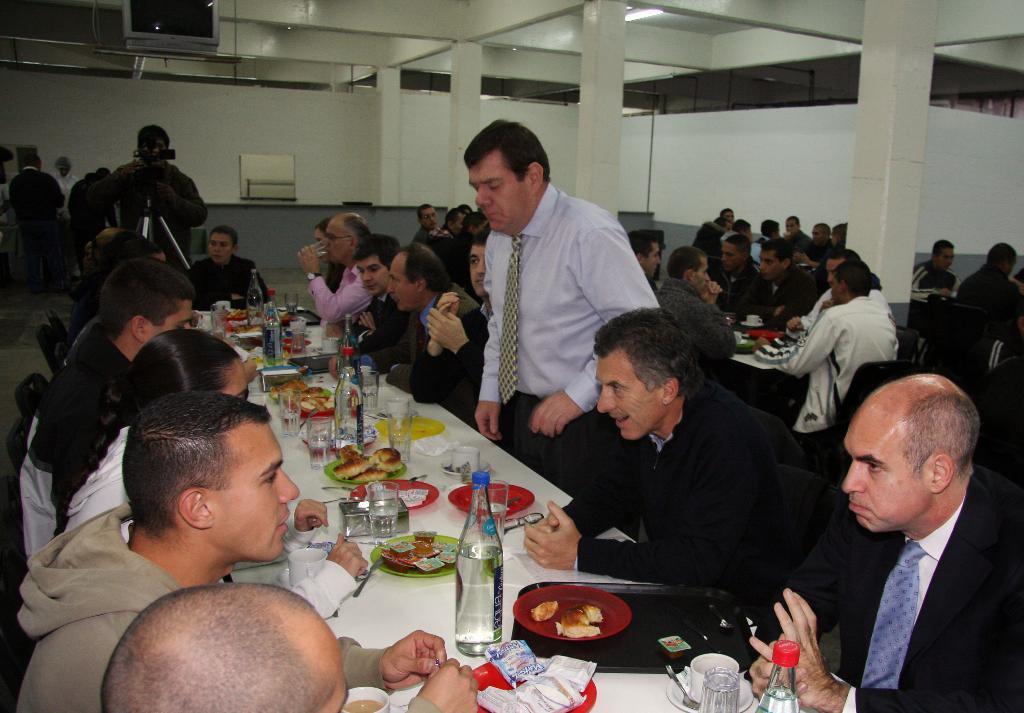Describe this image in one or two sentences. This is a picture taken in a hall, there are a group of people sitting on a chair in front of the people there is a table on top of the table there is a food, plate, bottle, glass, cup and saucer and the man in black jacket holding a camera with tripod stand. Background of this people is a white wall. 